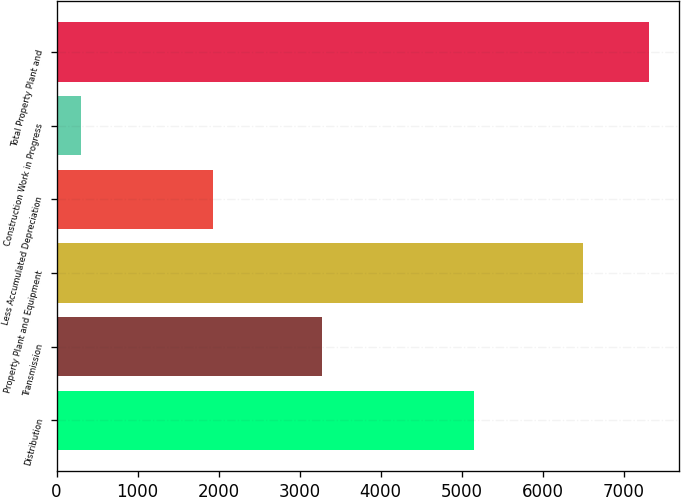<chart> <loc_0><loc_0><loc_500><loc_500><bar_chart><fcel>Distribution<fcel>Transmission<fcel>Property Plant and Equipment<fcel>Less Accumulated Depreciation<fcel>Construction Work in Progress<fcel>Total Property Plant and<nl><fcel>5158.8<fcel>3274<fcel>6504.8<fcel>1928<fcel>304.9<fcel>7317.59<nl></chart> 